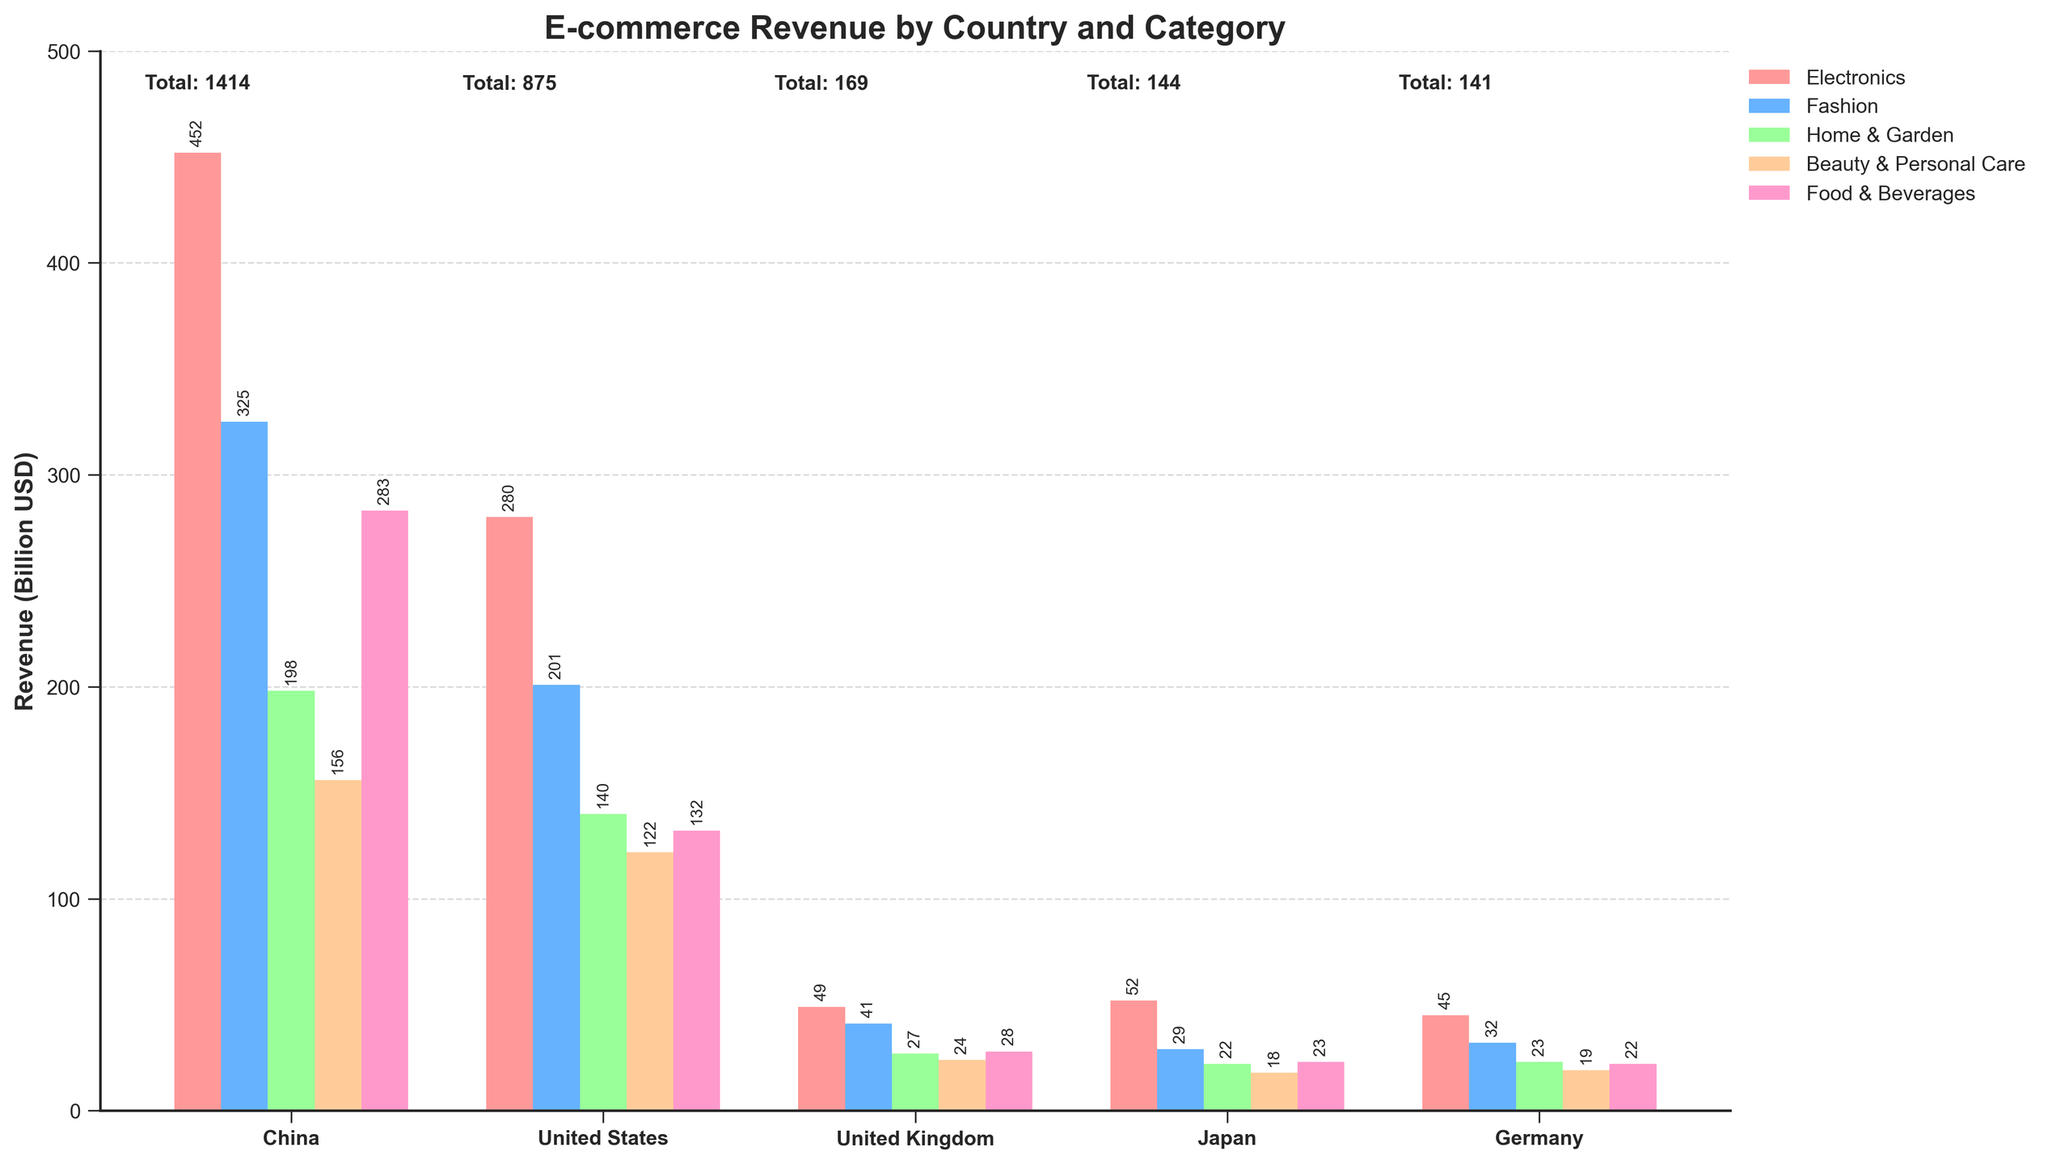What is the total e-commerce revenue for Japan? The bar for Japan's total revenue is labeled "Total: 144". This information is directly displayed above the country name on the bar chart.
Answer: 144 Which country has the highest revenue in Electronics? By observing the height of the "Electronics" bars and their corresponding labels, China has the highest revenue in Electronics with a value of 452 billion USD.
Answer: China Compare the revenue in Fashion for the United States and Japan. Which country has higher revenue, and by how much? The bar for Fashion in the United States is labeled 201 and for Japan it is labeled 29. The difference is calculated as 201 - 29 = 172. The United States has higher revenue.
Answer: United States, 172 What is the combined revenue from Home & Garden for the United Kingdom and Germany? The bar for Home & Garden in the United Kingdom is labeled 27 and for Germany it is labeled 23. The combined revenue is calculated as 27 + 23 = 50.
Answer: 50 Which product category has the lowest revenue in Germany? By checking the heights of the bars for Germany and their labels, the category with the lowest revenue is Beauty & Personal Care with a value of 19 billion USD.
Answer: Beauty & Personal Care How does the Food & Beverages revenue in China compare to the Food & Beverages revenue in the United States and Japan combined? The bar for Food & Beverages in China is labeled 283, in the United States it is labeled 132, and in Japan it is labeled 23. The combined revenue for the United States and Japan is 132 + 23 = 155. Therefore, China's revenue of 283 is higher when compared to 155.
Answer: China, higher Which product category contributes the most to the total revenue in the United Kingdom? By observing the heights of the bars in the United Kingdom and their labels, the category with the highest revenue is Electronics with a value of 49 billion USD.
Answer: Electronics What is the total e-commerce revenue of Home & Garden for all countries combined? Summing the Home & Garden revenues for all countries: 198 + 140 + 27 + 22 + 23 gives a total of 410 billion USD.
Answer: 410 What is the relationship between the total revenue and the revenue from Fashion for China? The total revenue for China is 1414 billion USD and the revenue from Fashion is 325 billion USD. To find the proportion, 325 / 1414 = 0.2299, which means Fashion contributes approximately 22.99% to the total revenue.
Answer: 22.99% Does Japan or Germany have a higher total e-commerce revenue, and what is the difference? Checking the total revenue labels, Japan has 144 billion USD and Germany has 141 billion USD in total revenue. The difference is calculated as 144 - 141 = 3.
Answer: Japan, 3 